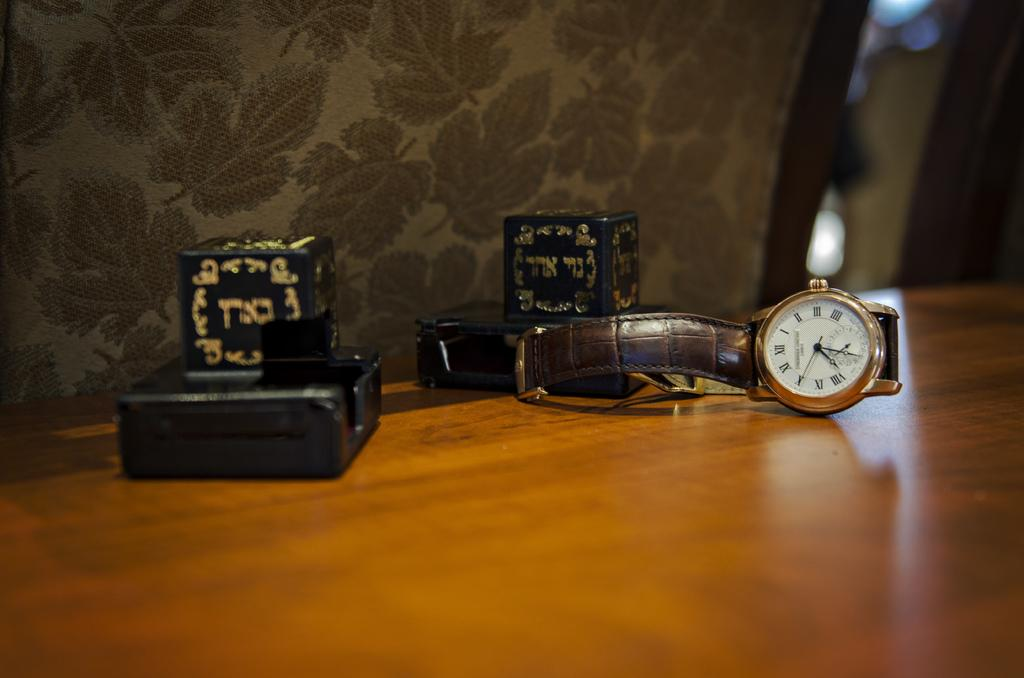Provide a one-sentence caption for the provided image. Watch on a table with the hands on number 12 and 1. 